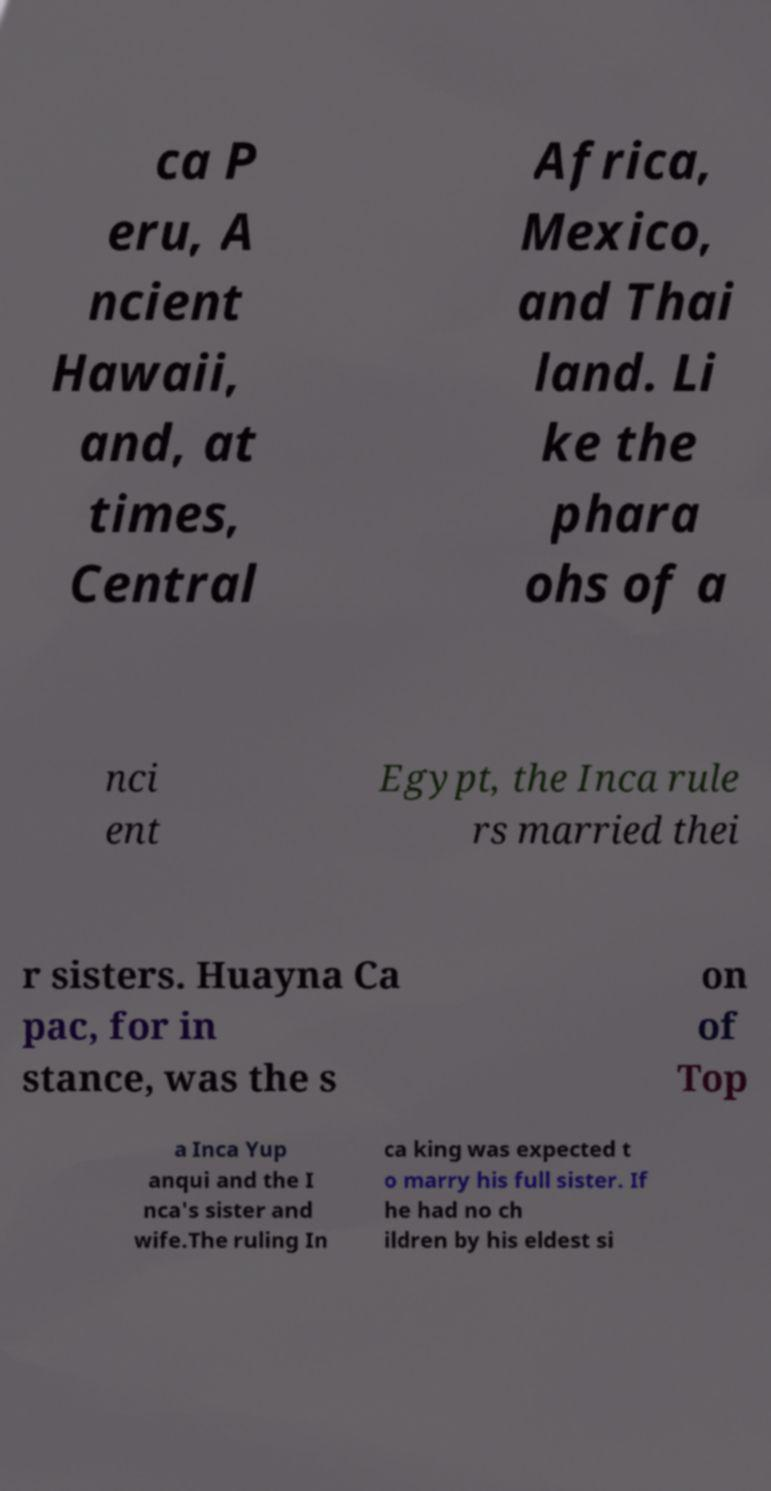Please read and relay the text visible in this image. What does it say? ca P eru, A ncient Hawaii, and, at times, Central Africa, Mexico, and Thai land. Li ke the phara ohs of a nci ent Egypt, the Inca rule rs married thei r sisters. Huayna Ca pac, for in stance, was the s on of Top a Inca Yup anqui and the I nca's sister and wife.The ruling In ca king was expected t o marry his full sister. If he had no ch ildren by his eldest si 